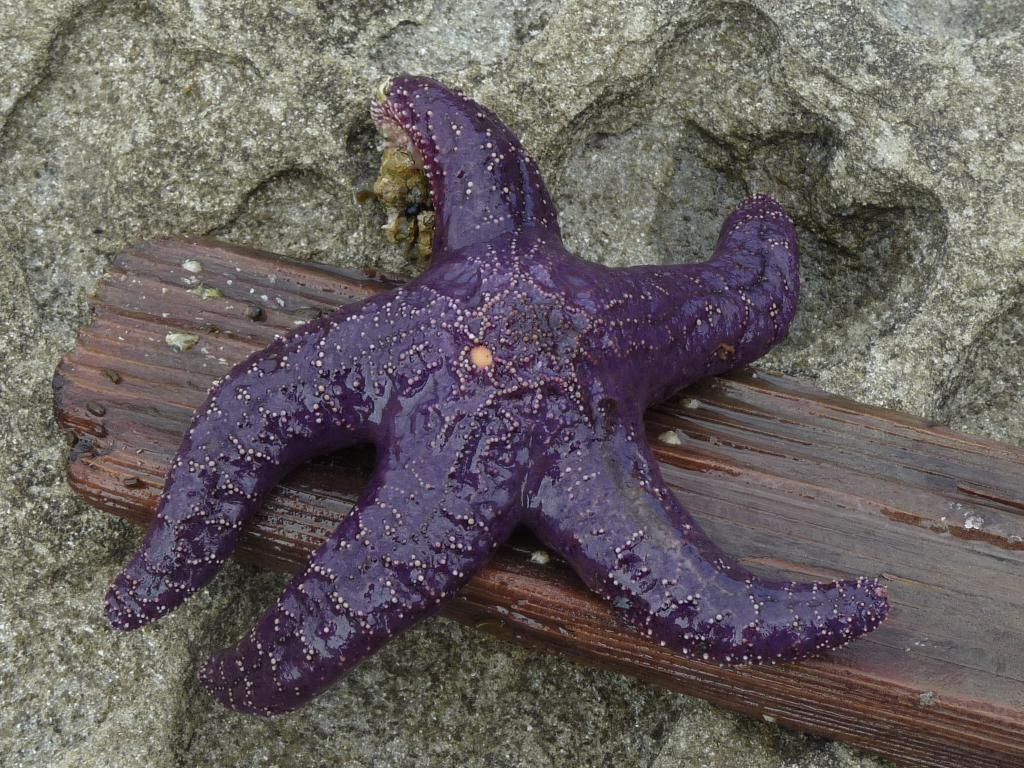What is the main subject of the image? The main subject of the image is a starfish. What is the starfish placed on? The starfish is on a wooden object. What type of surface can be seen in the background of the image? There is a stone surface visible in the background of the image. What type of shame can be seen on the starfish's face in the image? There is no indication of shame or any facial expression on the starfish, as it is an inanimate object. What type of beast is present in the image? There is no beast present in the image; it features a starfish on a wooden object. 